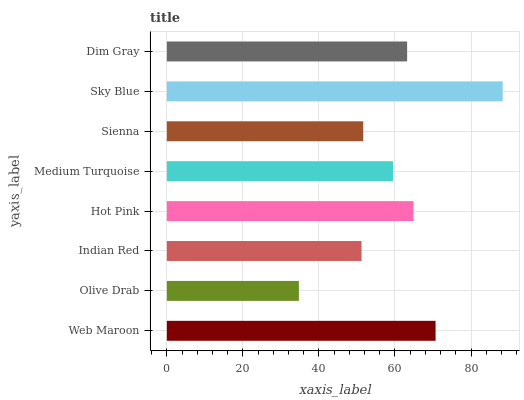Is Olive Drab the minimum?
Answer yes or no. Yes. Is Sky Blue the maximum?
Answer yes or no. Yes. Is Indian Red the minimum?
Answer yes or no. No. Is Indian Red the maximum?
Answer yes or no. No. Is Indian Red greater than Olive Drab?
Answer yes or no. Yes. Is Olive Drab less than Indian Red?
Answer yes or no. Yes. Is Olive Drab greater than Indian Red?
Answer yes or no. No. Is Indian Red less than Olive Drab?
Answer yes or no. No. Is Dim Gray the high median?
Answer yes or no. Yes. Is Medium Turquoise the low median?
Answer yes or no. Yes. Is Indian Red the high median?
Answer yes or no. No. Is Sky Blue the low median?
Answer yes or no. No. 